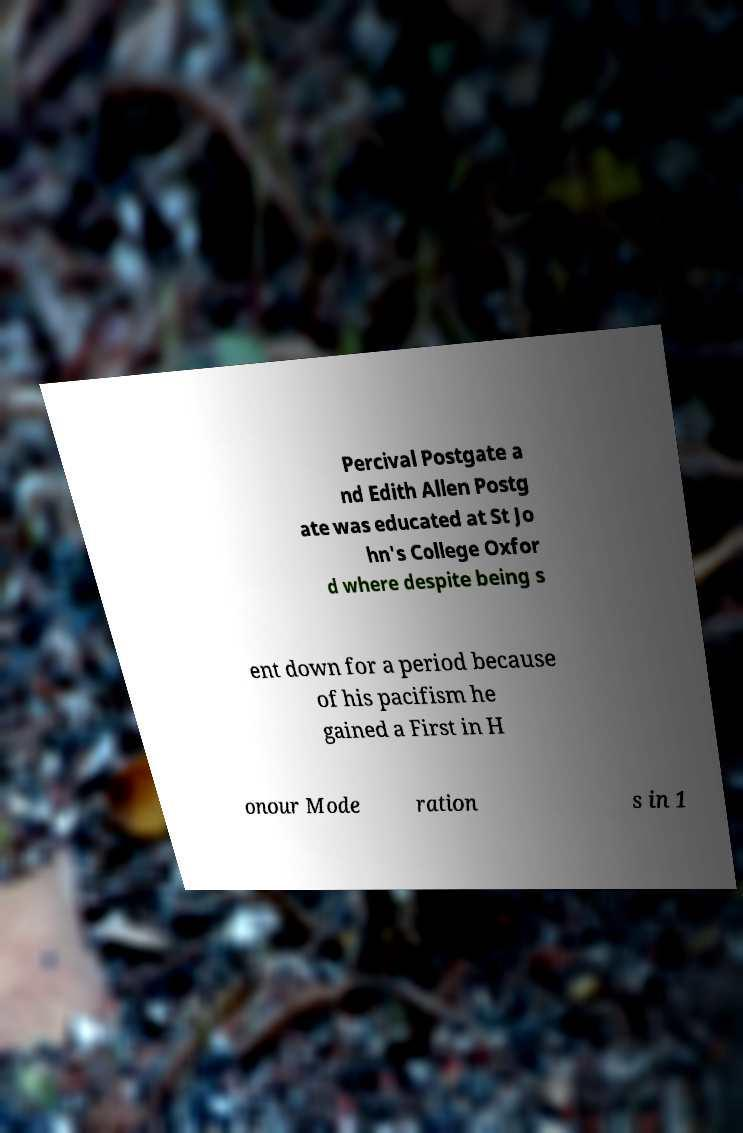What messages or text are displayed in this image? I need them in a readable, typed format. Percival Postgate a nd Edith Allen Postg ate was educated at St Jo hn's College Oxfor d where despite being s ent down for a period because of his pacifism he gained a First in H onour Mode ration s in 1 